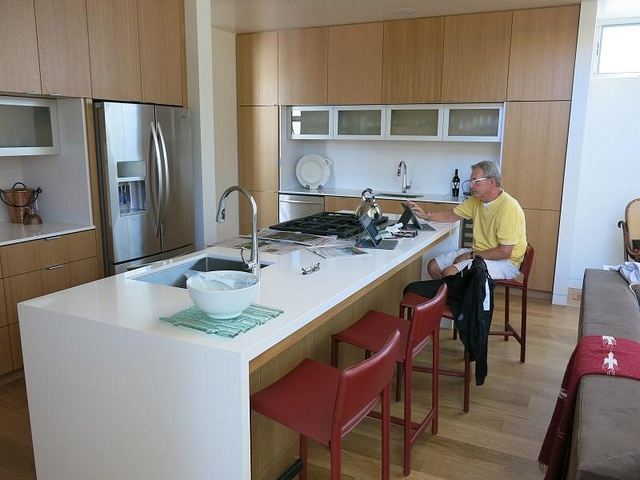Describe the objects in this image and their specific colors. I can see dining table in gray, darkgray, lightgray, and lightblue tones, refrigerator in gray, lightblue, black, and darkgray tones, couch in gray and brown tones, chair in gray, maroon, brown, and black tones, and chair in gray, maroon, black, and brown tones in this image. 